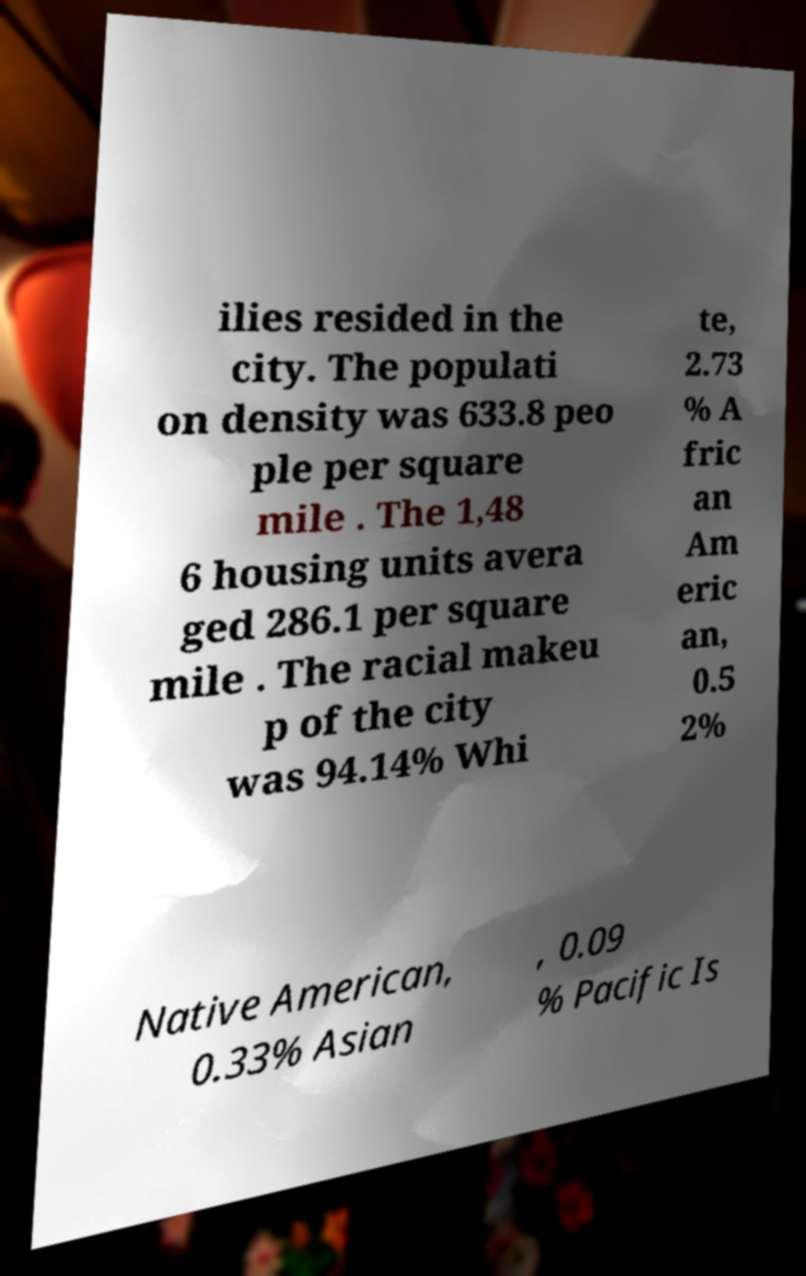Can you read and provide the text displayed in the image?This photo seems to have some interesting text. Can you extract and type it out for me? ilies resided in the city. The populati on density was 633.8 peo ple per square mile . The 1,48 6 housing units avera ged 286.1 per square mile . The racial makeu p of the city was 94.14% Whi te, 2.73 % A fric an Am eric an, 0.5 2% Native American, 0.33% Asian , 0.09 % Pacific Is 